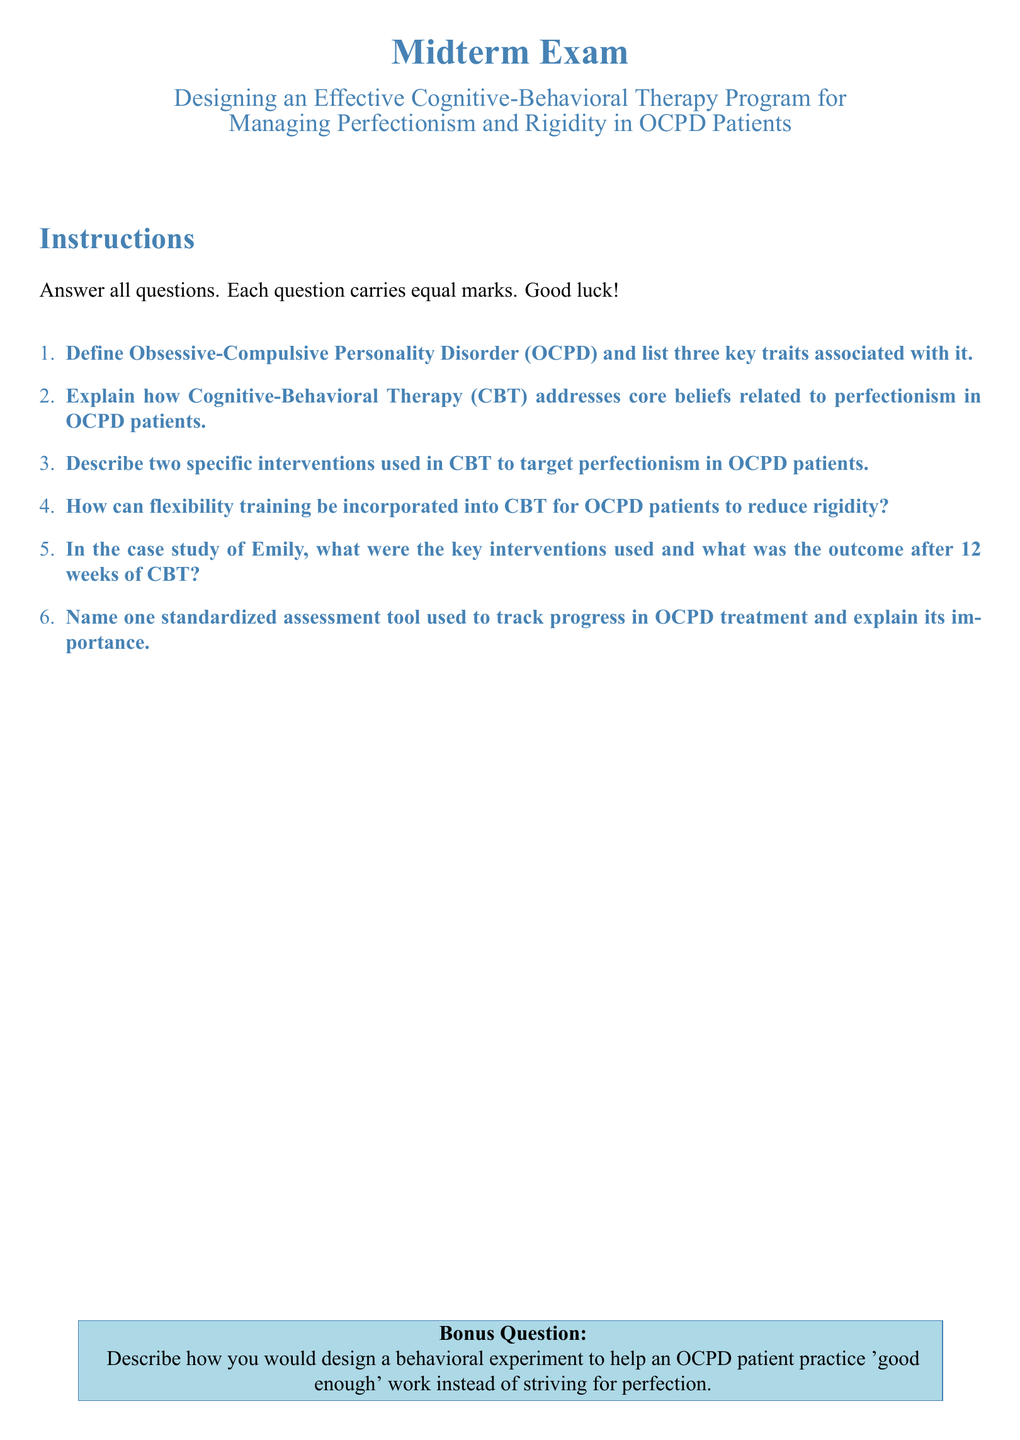Define OCPD The definition of OCPD is provided in the first question on the exam.
Answer: Obsessive-Compulsive Personality Disorder How many key traits are listed for OCPD? The first question specifies that three key traits are associated with OCPD.
Answer: Three What is the main therapeutic approach discussed in the document? The document outlines that CBT is the primary focus for managing OCPD.
Answer: Cognitive-Behavioral Therapy Name two specific interventions mentioned for targeting perfectionism in CBT. The third question asks for two types of interventions used in CBT.
Answer: Specific interventions What training is suggested to reduce rigidity in OCPD patients? The fourth question indicates that flexibility training is incorporated to address rigidity.
Answer: Flexibility training How long was the case study of Emily during the CBT treatment? The fifth question indicates that the treatment duration in the case study was 12 weeks.
Answer: 12 weeks What is the purpose of a standardized assessment tool in OCPD treatment? The sixth question highlights the role of assessment tools in tracking patient progress.
Answer: Tracking progress What is the bonus question focusing on? The bonus question describes a behavioral experiment for OCPD patients.
Answer: Behavioral experiment What color theme is used in this midterm exam document? The document consistently uses a specific color theme, identified in the styling.
Answer: ocpdblue and ocpdlightblue 